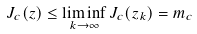Convert formula to latex. <formula><loc_0><loc_0><loc_500><loc_500>J _ { c } ( z ) \leq \liminf _ { k \to \infty } J _ { c } ( z _ { k } ) = m _ { c }</formula> 